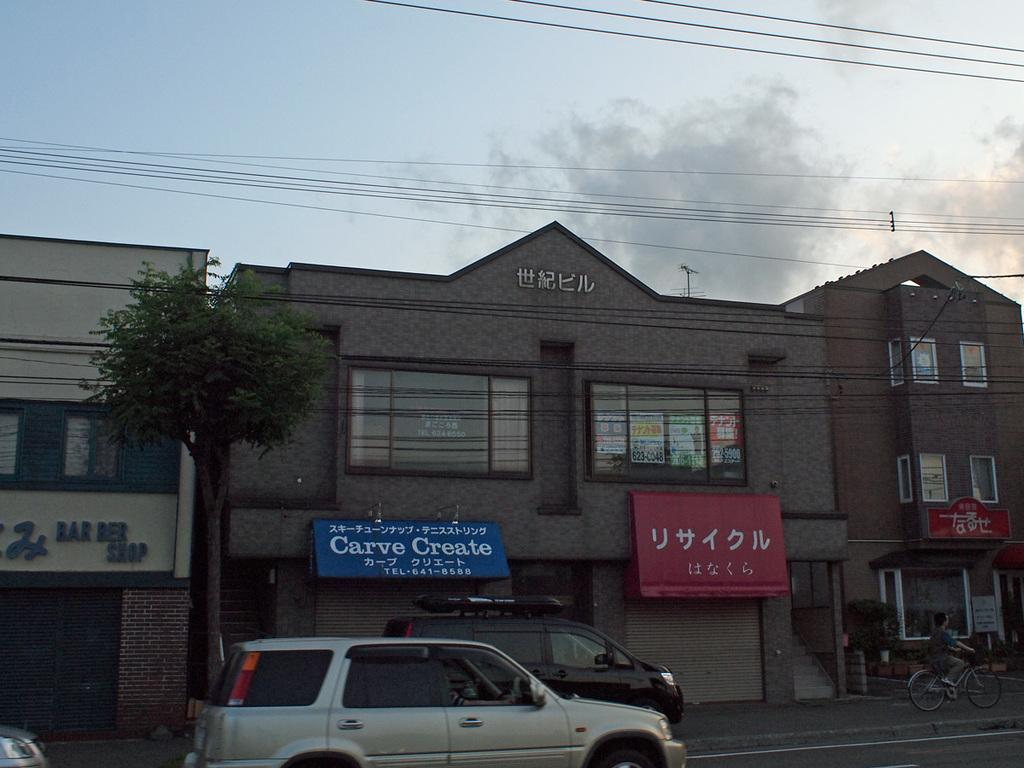What type of structures can be seen in the image? There are buildings in the image. What mode of transportation is present in the image? There are cars in the image. What type of decoration or signage is visible in the image? There are banners in the image. What type of plant is present in the image? There is a tree in the image. What activity is being performed by a person in the image? There is a person riding a bicycle in the image. What architectural feature can be seen on the buildings in the image? There are windows visible in the image. What part of the natural environment is visible in the image? The sky is visible in the image, and clouds are present in the sky. How many balls are being juggled by the girls in the image? There are no girls or balls present in the image. What type of river can be seen flowing through the buildings in the image? There is no river present in the image; it features buildings, cars, banners, a tree, a person riding a bicycle, windows, and the sky with clouds. 